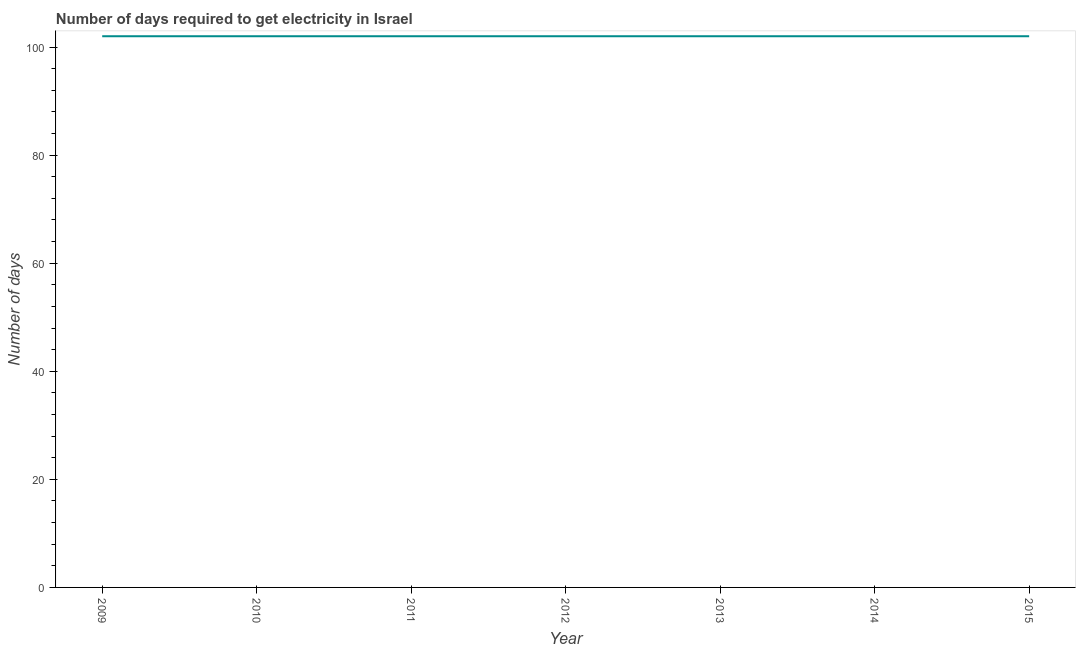What is the time to get electricity in 2009?
Offer a terse response. 102. Across all years, what is the maximum time to get electricity?
Make the answer very short. 102. Across all years, what is the minimum time to get electricity?
Ensure brevity in your answer.  102. In which year was the time to get electricity maximum?
Offer a very short reply. 2009. What is the sum of the time to get electricity?
Your answer should be compact. 714. What is the difference between the time to get electricity in 2010 and 2014?
Provide a succinct answer. 0. What is the average time to get electricity per year?
Make the answer very short. 102. What is the median time to get electricity?
Your answer should be very brief. 102. What is the ratio of the time to get electricity in 2012 to that in 2015?
Provide a short and direct response. 1. Is the time to get electricity in 2010 less than that in 2011?
Give a very brief answer. No. In how many years, is the time to get electricity greater than the average time to get electricity taken over all years?
Make the answer very short. 0. Does the time to get electricity monotonically increase over the years?
Offer a very short reply. No. How many lines are there?
Your answer should be very brief. 1. How many years are there in the graph?
Provide a short and direct response. 7. What is the difference between two consecutive major ticks on the Y-axis?
Give a very brief answer. 20. Are the values on the major ticks of Y-axis written in scientific E-notation?
Your answer should be very brief. No. Does the graph contain any zero values?
Offer a terse response. No. What is the title of the graph?
Your answer should be very brief. Number of days required to get electricity in Israel. What is the label or title of the Y-axis?
Ensure brevity in your answer.  Number of days. What is the Number of days of 2009?
Give a very brief answer. 102. What is the Number of days of 2010?
Offer a very short reply. 102. What is the Number of days of 2011?
Give a very brief answer. 102. What is the Number of days of 2012?
Provide a short and direct response. 102. What is the Number of days of 2013?
Provide a succinct answer. 102. What is the Number of days in 2014?
Give a very brief answer. 102. What is the Number of days in 2015?
Your answer should be very brief. 102. What is the difference between the Number of days in 2009 and 2010?
Keep it short and to the point. 0. What is the difference between the Number of days in 2009 and 2011?
Provide a short and direct response. 0. What is the difference between the Number of days in 2009 and 2012?
Give a very brief answer. 0. What is the difference between the Number of days in 2010 and 2011?
Keep it short and to the point. 0. What is the difference between the Number of days in 2010 and 2012?
Your response must be concise. 0. What is the difference between the Number of days in 2010 and 2014?
Offer a very short reply. 0. What is the difference between the Number of days in 2011 and 2013?
Your response must be concise. 0. What is the difference between the Number of days in 2013 and 2015?
Your answer should be very brief. 0. What is the ratio of the Number of days in 2009 to that in 2011?
Make the answer very short. 1. What is the ratio of the Number of days in 2009 to that in 2013?
Ensure brevity in your answer.  1. What is the ratio of the Number of days in 2009 to that in 2014?
Offer a very short reply. 1. What is the ratio of the Number of days in 2010 to that in 2012?
Ensure brevity in your answer.  1. What is the ratio of the Number of days in 2010 to that in 2015?
Give a very brief answer. 1. What is the ratio of the Number of days in 2011 to that in 2012?
Provide a succinct answer. 1. What is the ratio of the Number of days in 2011 to that in 2013?
Your response must be concise. 1. What is the ratio of the Number of days in 2011 to that in 2014?
Keep it short and to the point. 1. What is the ratio of the Number of days in 2011 to that in 2015?
Give a very brief answer. 1. What is the ratio of the Number of days in 2013 to that in 2014?
Offer a terse response. 1. What is the ratio of the Number of days in 2014 to that in 2015?
Your answer should be compact. 1. 